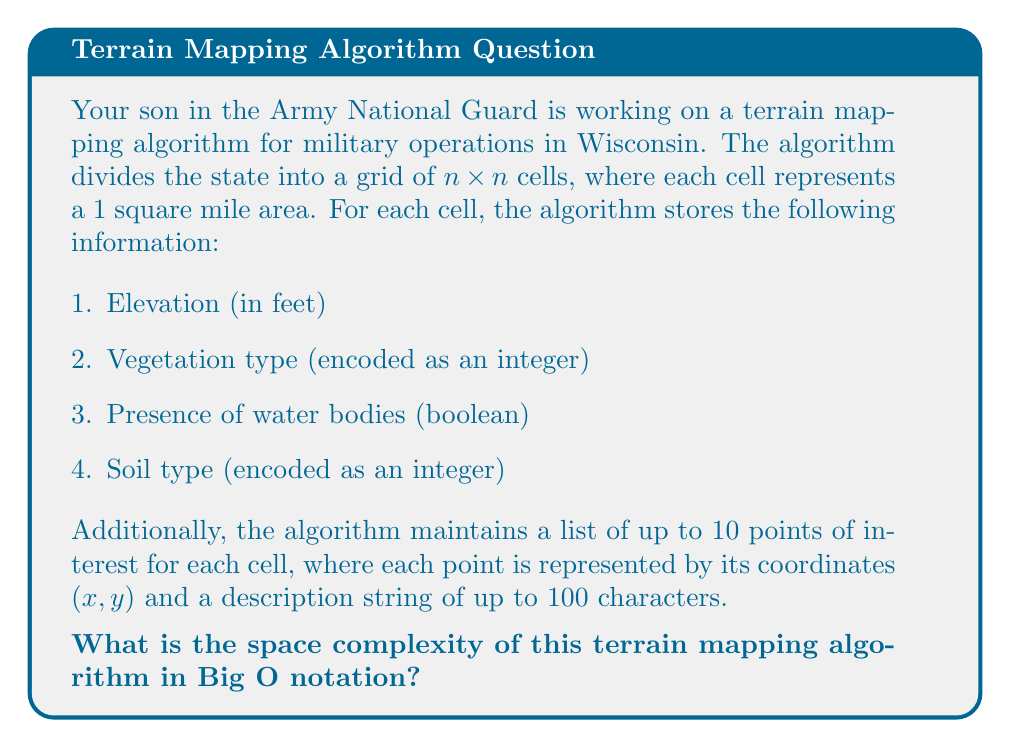What is the answer to this math problem? Let's break down the space requirements step by step:

1. Grid size: The grid is $n \times n$, so we have $n^2$ cells in total.

2. For each cell, we store:
   - Elevation: 4 bytes (assuming a 32-bit float)
   - Vegetation type: 4 bytes (assuming a 32-bit integer)
   - Water presence: 1 byte (boolean)
   - Soil type: 4 bytes (assuming a 32-bit integer)
   Total per cell: 13 bytes

3. Points of interest:
   - Each cell can have up to 10 points
   - Each point has:
     * x-coordinate: 4 bytes
     * y-coordinate: 4 bytes
     * Description: 100 bytes (100 characters)
   Total per point: 108 bytes
   Maximum total per cell for points: 10 * 108 = 1080 bytes

4. Total storage per cell:
   13 bytes (basic info) + 1080 bytes (points of interest) = 1093 bytes

5. Total storage for the entire grid:
   $n^2 * 1093$ bytes

The space complexity is proportional to the number of cells, which is $n^2$. The constant factor (1093) doesn't affect the Big O notation.

Therefore, the space complexity of this terrain mapping algorithm is $O(n^2)$.
Answer: $O(n^2)$ 